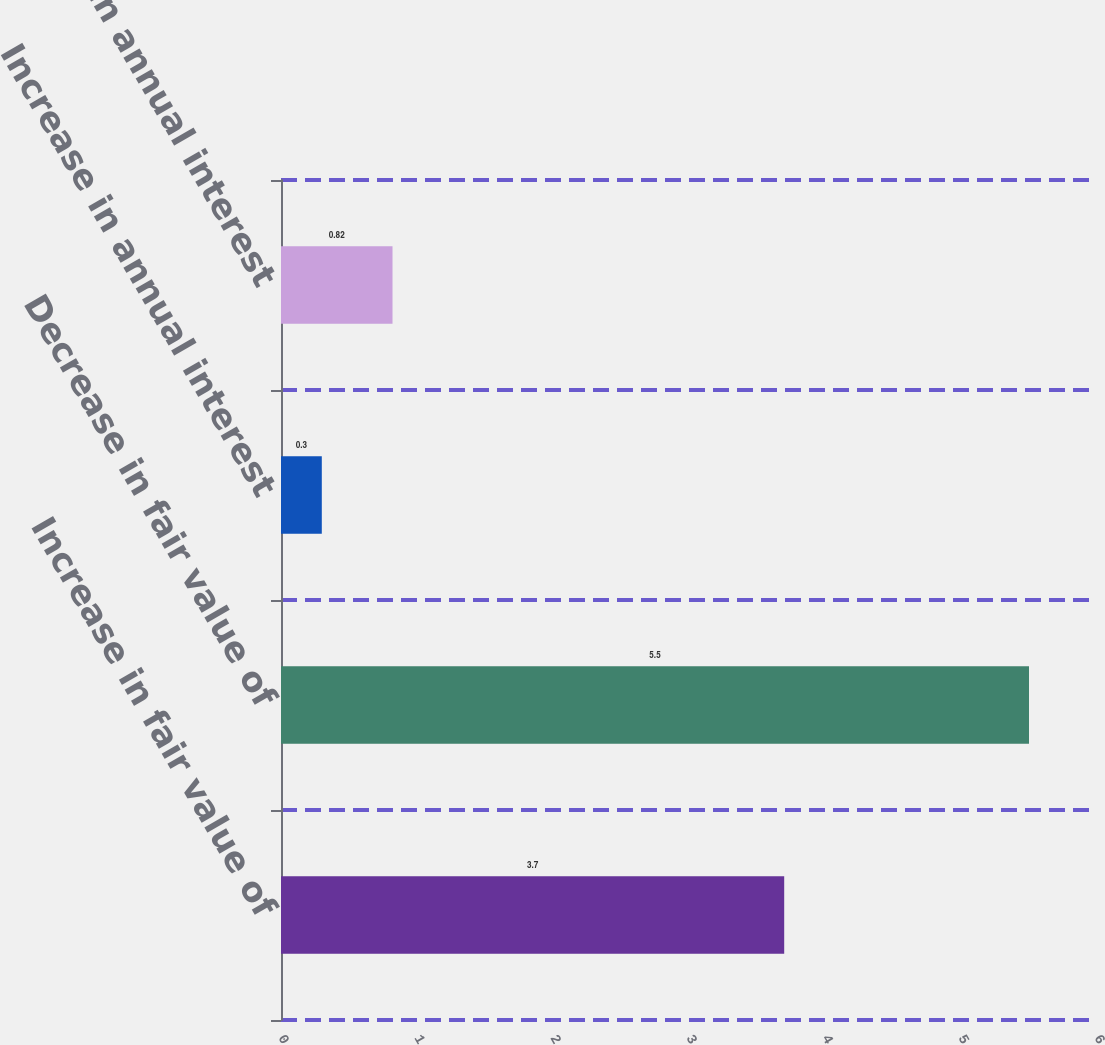Convert chart. <chart><loc_0><loc_0><loc_500><loc_500><bar_chart><fcel>Increase in fair value of<fcel>Decrease in fair value of<fcel>Increase in annual interest<fcel>Decrease in annual interest<nl><fcel>3.7<fcel>5.5<fcel>0.3<fcel>0.82<nl></chart> 